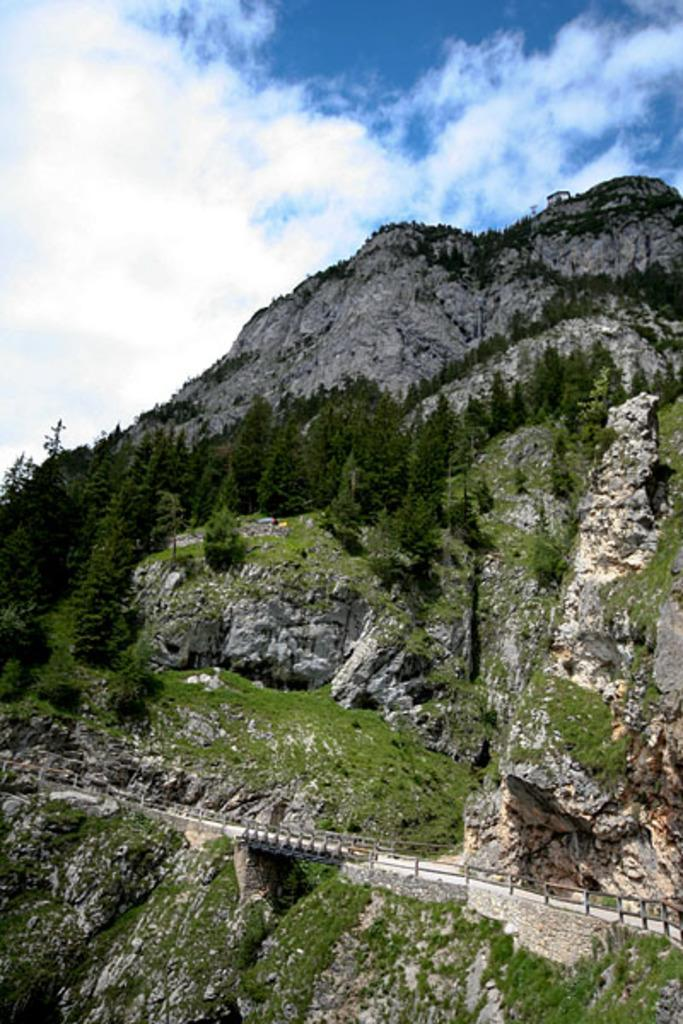What can be seen in the background of the image? The sky and clouds are visible in the background of the image. What is the main landscape feature in the image? The image is mainly highlighted with hills. What type of vegetation is present in the image? There is thicket in the image. What type of man-made structure can be seen in the image? There is a road and a railing in the image. How many rabbits can be seen rolling down the hill in the image? There are no rabbits present in the image, and therefore no such activity can be observed. 